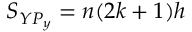<formula> <loc_0><loc_0><loc_500><loc_500>S _ { Y P _ { y } } = n ( 2 k + 1 ) h</formula> 